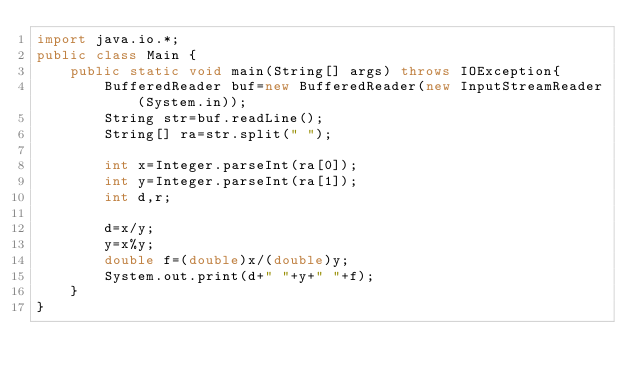<code> <loc_0><loc_0><loc_500><loc_500><_Java_>import java.io.*;
public class Main {
    public static void main(String[] args) throws IOException{
        BufferedReader buf=new BufferedReader(new InputStreamReader(System.in));
        String str=buf.readLine();
        String[] ra=str.split(" ");
        
        int x=Integer.parseInt(ra[0]);
        int y=Integer.parseInt(ra[1]);
        int d,r;
        
        d=x/y;
        y=x%y;
        double f=(double)x/(double)y;
        System.out.print(d+" "+y+" "+f);
    }
}</code> 